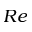Convert formula to latex. <formula><loc_0><loc_0><loc_500><loc_500>R e</formula> 